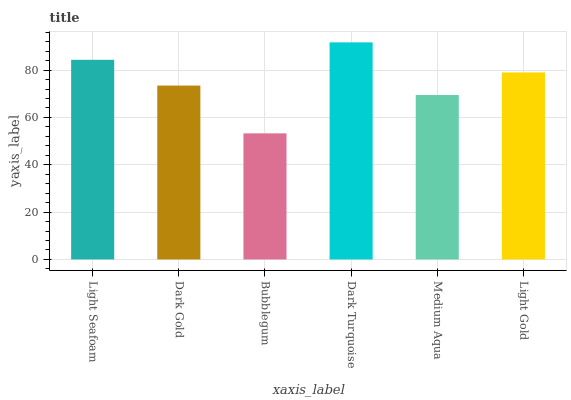Is Bubblegum the minimum?
Answer yes or no. Yes. Is Dark Turquoise the maximum?
Answer yes or no. Yes. Is Dark Gold the minimum?
Answer yes or no. No. Is Dark Gold the maximum?
Answer yes or no. No. Is Light Seafoam greater than Dark Gold?
Answer yes or no. Yes. Is Dark Gold less than Light Seafoam?
Answer yes or no. Yes. Is Dark Gold greater than Light Seafoam?
Answer yes or no. No. Is Light Seafoam less than Dark Gold?
Answer yes or no. No. Is Light Gold the high median?
Answer yes or no. Yes. Is Dark Gold the low median?
Answer yes or no. Yes. Is Medium Aqua the high median?
Answer yes or no. No. Is Light Gold the low median?
Answer yes or no. No. 